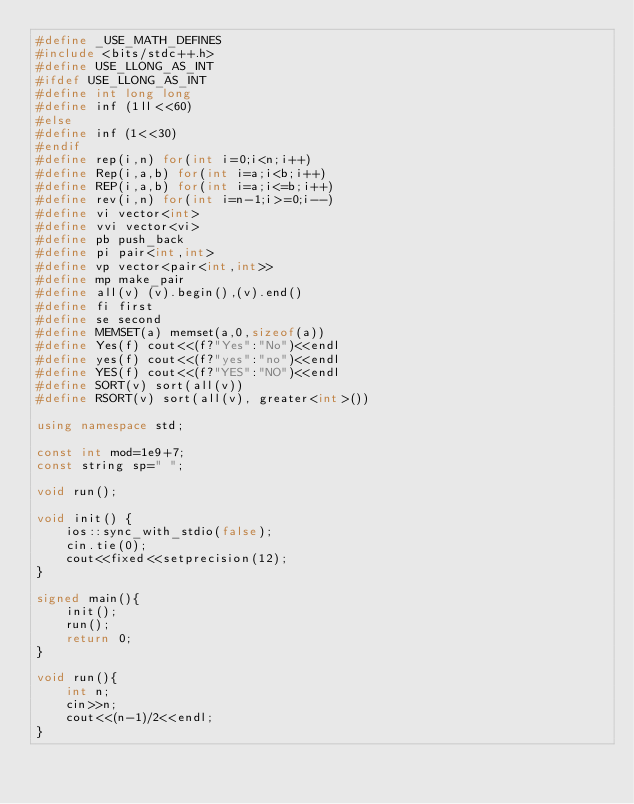Convert code to text. <code><loc_0><loc_0><loc_500><loc_500><_C++_>#define _USE_MATH_DEFINES
#include <bits/stdc++.h>
#define USE_LLONG_AS_INT
#ifdef USE_LLONG_AS_INT
#define int long long
#define inf (1ll<<60)
#else
#define inf (1<<30)
#endif
#define rep(i,n) for(int i=0;i<n;i++)
#define Rep(i,a,b) for(int i=a;i<b;i++)
#define REP(i,a,b) for(int i=a;i<=b;i++)
#define rev(i,n) for(int i=n-1;i>=0;i--)
#define vi vector<int>
#define vvi vector<vi>
#define pb push_back
#define pi pair<int,int>
#define vp vector<pair<int,int>>
#define mp make_pair
#define all(v) (v).begin(),(v).end()
#define fi first
#define se second
#define MEMSET(a) memset(a,0,sizeof(a))
#define Yes(f) cout<<(f?"Yes":"No")<<endl
#define yes(f) cout<<(f?"yes":"no")<<endl
#define YES(f) cout<<(f?"YES":"NO")<<endl
#define SORT(v) sort(all(v))
#define RSORT(v) sort(all(v), greater<int>())

using namespace std;

const int mod=1e9+7;
const string sp=" ";

void run();

void init() {
    ios::sync_with_stdio(false);
    cin.tie(0);
    cout<<fixed<<setprecision(12);
}

signed main(){
    init();
    run();
    return 0;
}

void run(){
    int n;
    cin>>n;
    cout<<(n-1)/2<<endl;
}</code> 